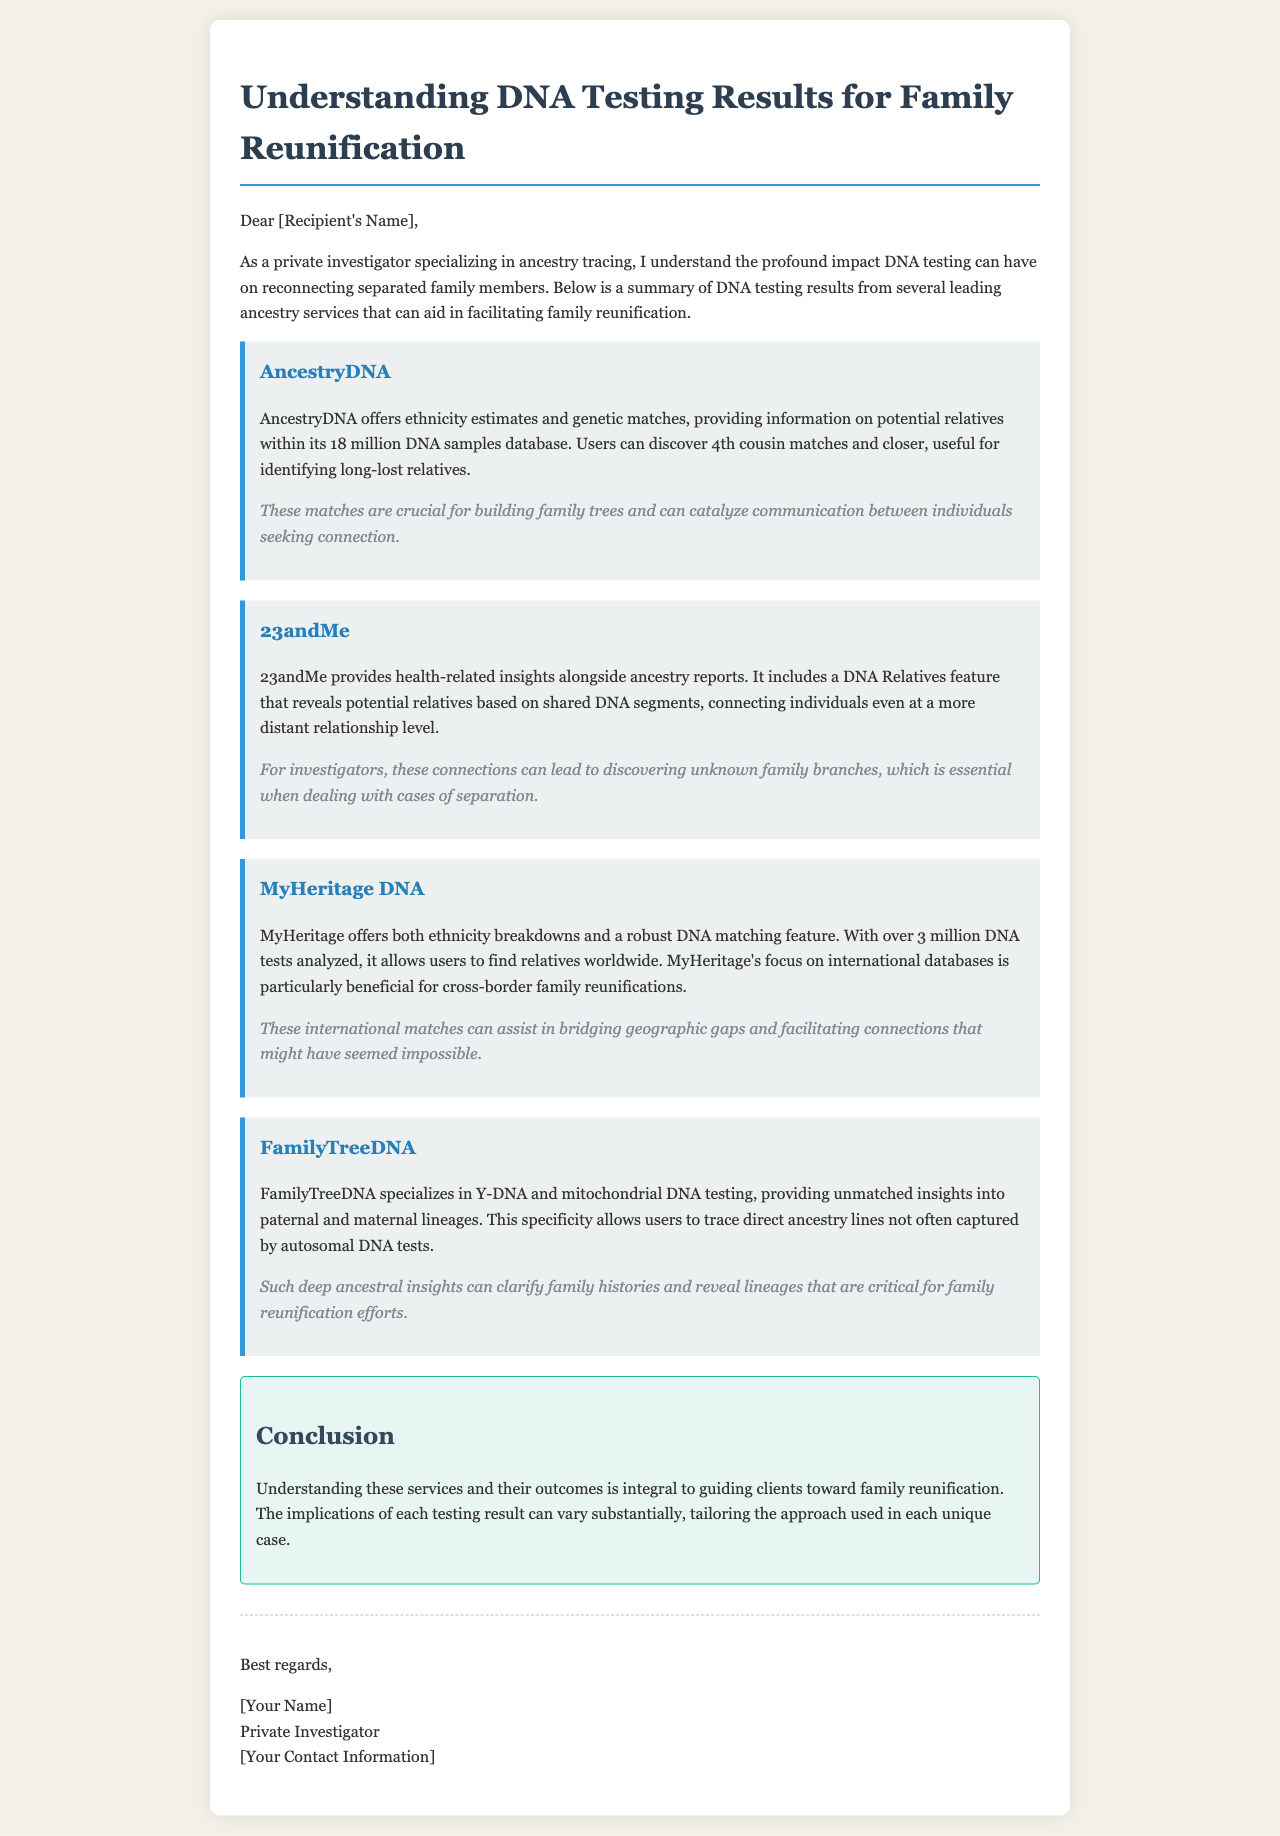What is the primary purpose of the email? The primary purpose of the email is to summarize DNA testing results from different ancestry services that can aid in facilitating family reunification.
Answer: Family reunification How many DNA samples does AncestryDNA's database contain? AncestryDNA's database contains 18 million DNA samples.
Answer: 18 million What feature does 23andMe provide to reveal potential relatives? 23andMe provides a DNA Relatives feature that reveals potential relatives based on shared DNA segments.
Answer: DNA Relatives What is the focus of MyHeritage's database? MyHeritage's focus is on international databases, which is particularly beneficial for cross-border family reunifications.
Answer: International databases Which service specializes in Y-DNA and mitochondrial DNA testing? FamilyTreeDNA specializes in Y-DNA and mitochondrial DNA testing.
Answer: FamilyTreeDNA What can the insights from FamilyTreeDNA clarify? The insights from FamilyTreeDNA can clarify family histories and reveal lineages that are critical for family reunification efforts.
Answer: Family histories What is the consequence of the DNA matches from AncestryDNA? The DNA matches from AncestryDNA are crucial for building family trees and can catalyze communication between individuals seeking connection.
Answer: Build family trees Which service analyzes over 3 million DNA tests? MyHeritage analyzes over 3 million DNA tests.
Answer: MyHeritage What is emphasized in the conclusion of the email? The conclusion emphasizes the importance of understanding the DNA testing services and their outcomes for guiding clients toward family reunification.
Answer: Understanding the services 